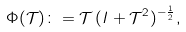<formula> <loc_0><loc_0><loc_500><loc_500>\Phi ( \mathcal { T } ) \colon = \mathcal { T } \, ( I + \mathcal { T } ^ { 2 } ) ^ { - \frac { 1 } { 2 } } ,</formula> 